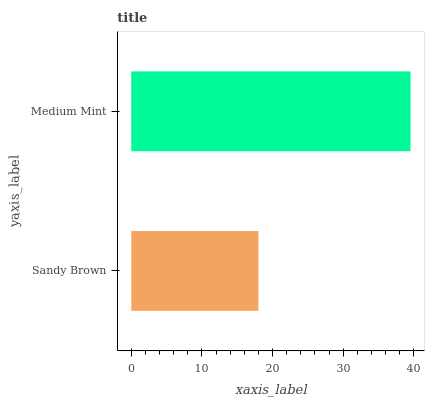Is Sandy Brown the minimum?
Answer yes or no. Yes. Is Medium Mint the maximum?
Answer yes or no. Yes. Is Medium Mint the minimum?
Answer yes or no. No. Is Medium Mint greater than Sandy Brown?
Answer yes or no. Yes. Is Sandy Brown less than Medium Mint?
Answer yes or no. Yes. Is Sandy Brown greater than Medium Mint?
Answer yes or no. No. Is Medium Mint less than Sandy Brown?
Answer yes or no. No. Is Medium Mint the high median?
Answer yes or no. Yes. Is Sandy Brown the low median?
Answer yes or no. Yes. Is Sandy Brown the high median?
Answer yes or no. No. Is Medium Mint the low median?
Answer yes or no. No. 